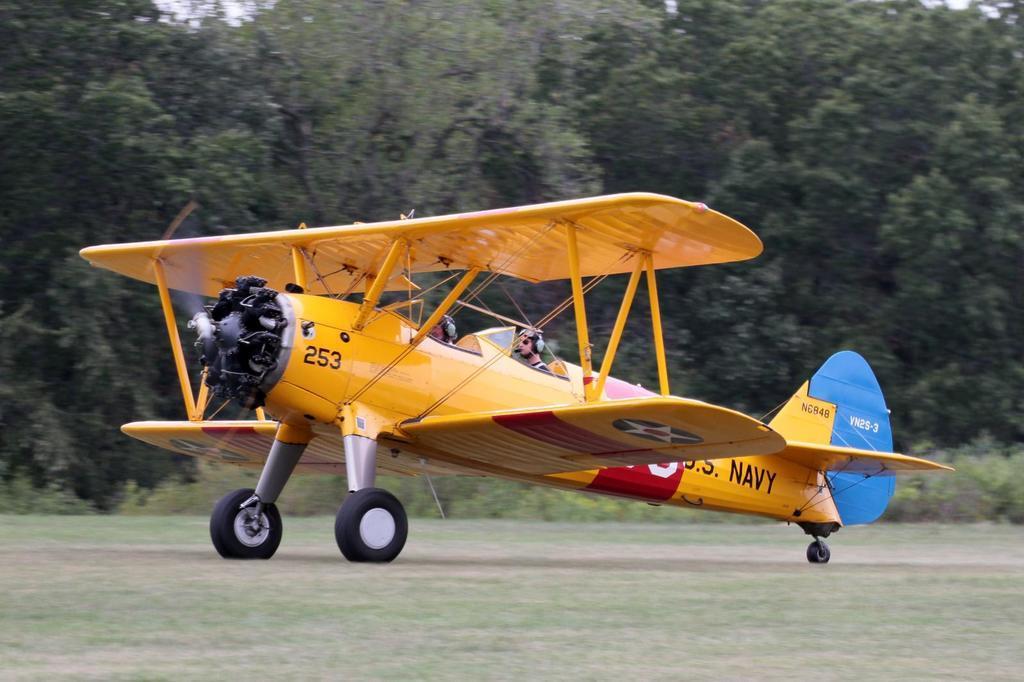Please provide a concise description of this image. In this image I can see an open ground and in the centre I can see a yellow colour aircraft. I can also see two persons are sitting in it and in the background I can see number of trees and plants. 